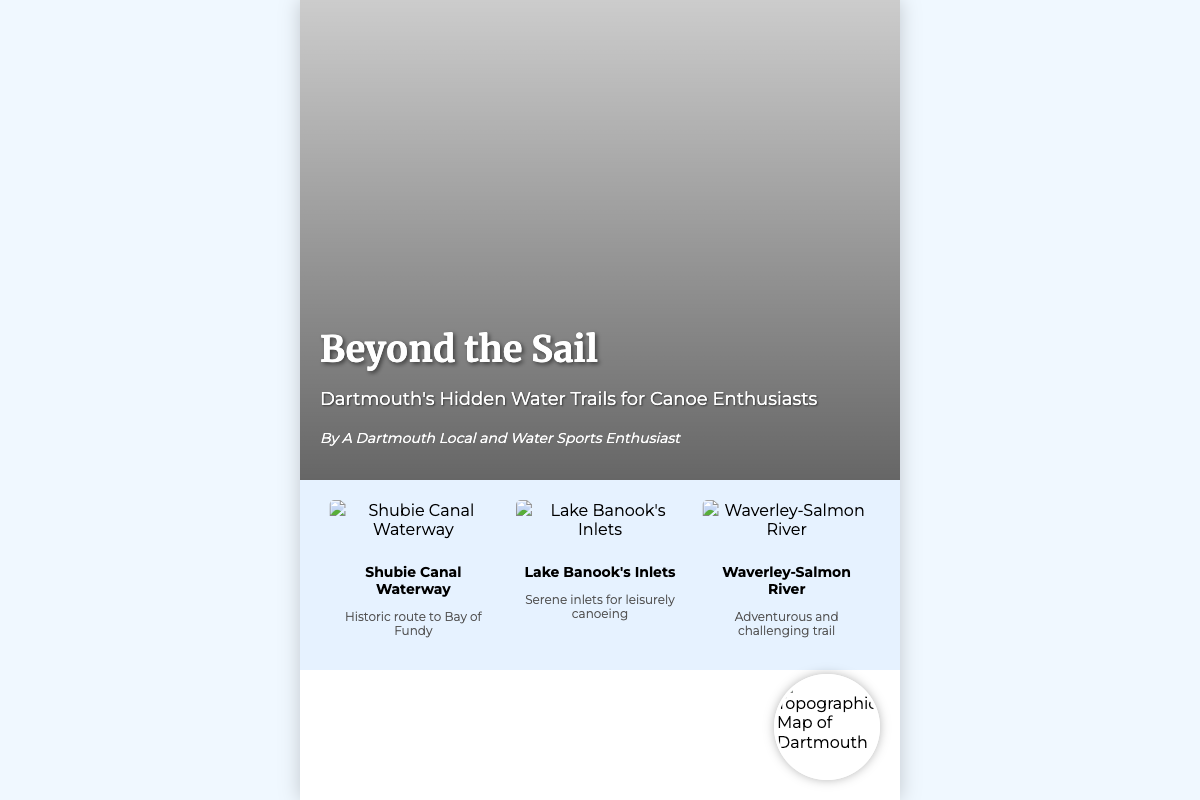What is the title of the book? The title of the book is prominently displayed on the cover, which is "Beyond the Sail".
Answer: Beyond the Sail Who is the author of the book? The author is mentioned as "A Dartmouth Local and Water Sports Enthusiast".
Answer: A Dartmouth Local and Water Sports Enthusiast What are the featured trails listed on the cover? The book cover includes three featured trails: Shubie Canal Waterway, Lake Banook's Inlets, and Waverley-Salmon River.
Answer: Shubie Canal Waterway, Lake Banook's Inlets, Waverley-Salmon River What type of imagery is used in the book? The visual elements include topographic maps and lush landscape imagery, as stated in the overview.
Answer: Topographic maps, lush landscape imagery What is the main focus of the book? The main focus of the book is exploring lesser-known waterways that are perfect for canoeing enthusiasts.
Answer: Lesser-known waterways for canoeing What does the image in the map container depict? The map container shows a topographic map of Dartmouth, which is relevant to the content of the book.
Answer: Topographic Map of Dartmouth Which trail is described as "Adventurous and challenging"? The Waverley-Salmon River trail is specifically described with this phrase.
Answer: Waverley-Salmon River Which waterway is a historic route to the Bay of Fundy? The Shubie Canal Waterway is identified as a historic route to the Bay of Fundy.
Answer: Shubie Canal Waterway 